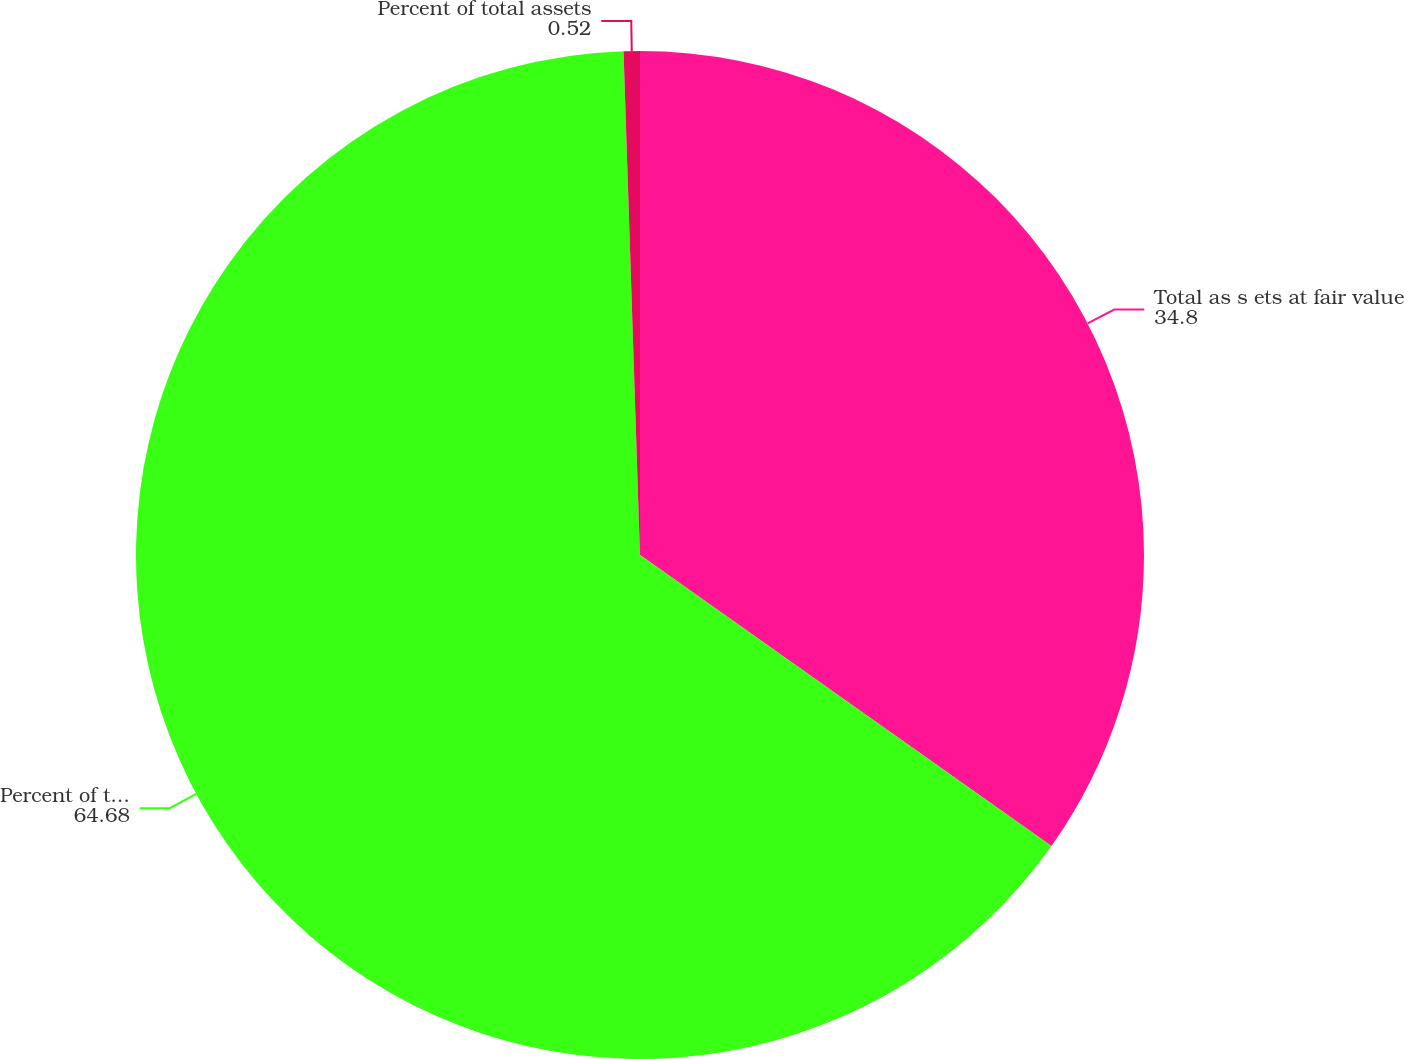<chart> <loc_0><loc_0><loc_500><loc_500><pie_chart><fcel>Total as s ets at fair value<fcel>Percent of total assets at<fcel>Percent of total assets<nl><fcel>34.8%<fcel>64.68%<fcel>0.52%<nl></chart> 